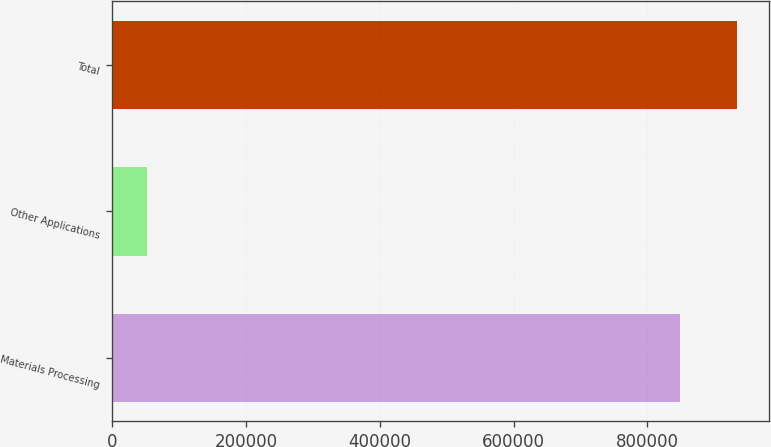Convert chart. <chart><loc_0><loc_0><loc_500><loc_500><bar_chart><fcel>Materials Processing<fcel>Other Applications<fcel>Total<nl><fcel>849335<fcel>51930<fcel>934268<nl></chart> 